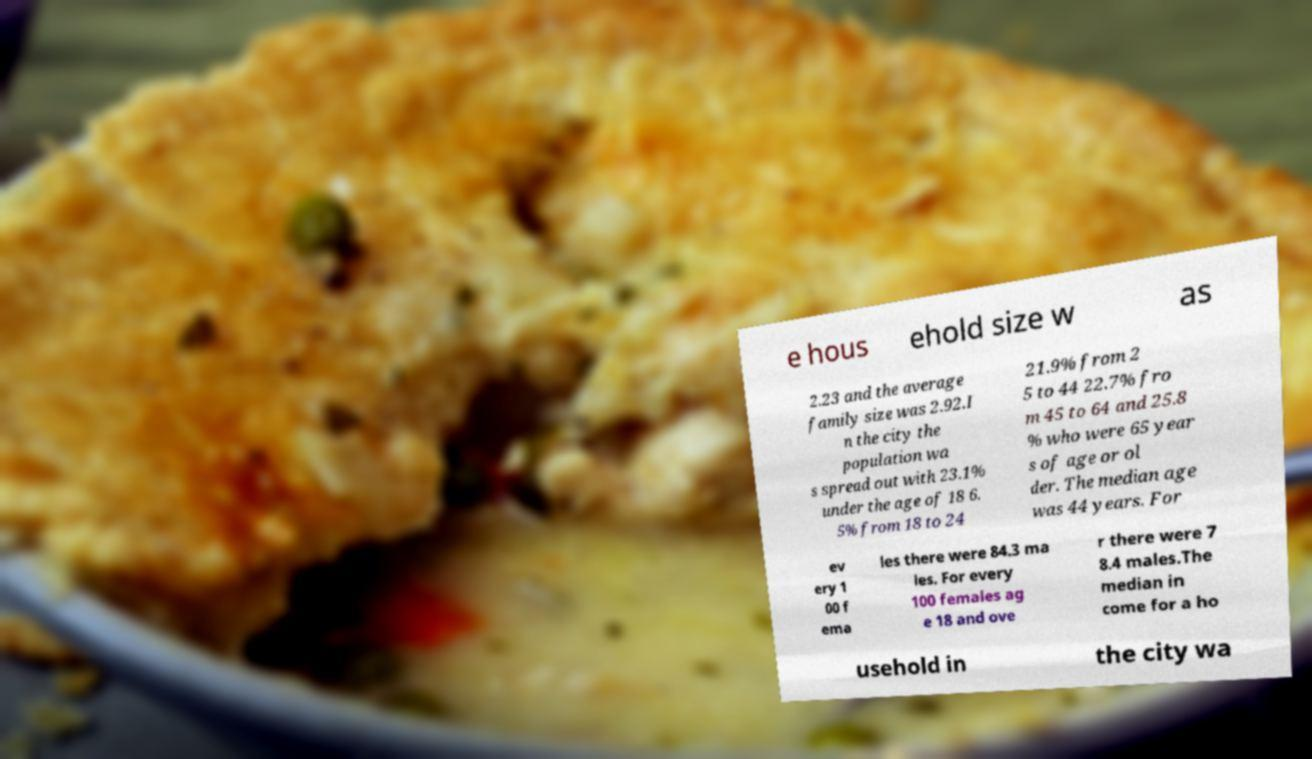Please identify and transcribe the text found in this image. e hous ehold size w as 2.23 and the average family size was 2.92.I n the city the population wa s spread out with 23.1% under the age of 18 6. 5% from 18 to 24 21.9% from 2 5 to 44 22.7% fro m 45 to 64 and 25.8 % who were 65 year s of age or ol der. The median age was 44 years. For ev ery 1 00 f ema les there were 84.3 ma les. For every 100 females ag e 18 and ove r there were 7 8.4 males.The median in come for a ho usehold in the city wa 